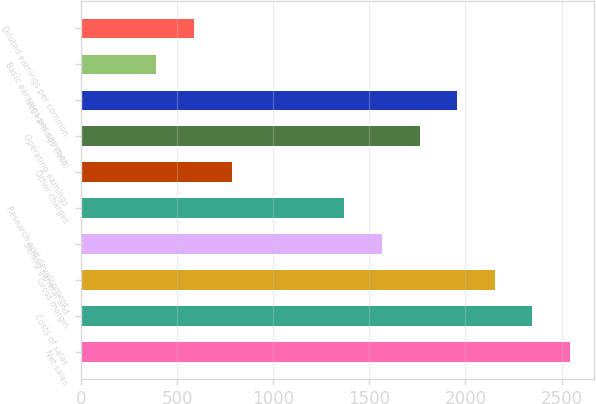Convert chart to OTSL. <chart><loc_0><loc_0><loc_500><loc_500><bar_chart><fcel>Net sales<fcel>Costs of sales<fcel>Gross margin<fcel>Selling general and<fcel>Research and development<fcel>Other charges<fcel>Operating earnings<fcel>Net earnings (loss)<fcel>Basic earnings per common<fcel>Diluted earnings per common<nl><fcel>2543.92<fcel>2348.27<fcel>2152.62<fcel>1565.67<fcel>1370.02<fcel>783.07<fcel>1761.32<fcel>1956.97<fcel>391.77<fcel>587.42<nl></chart> 